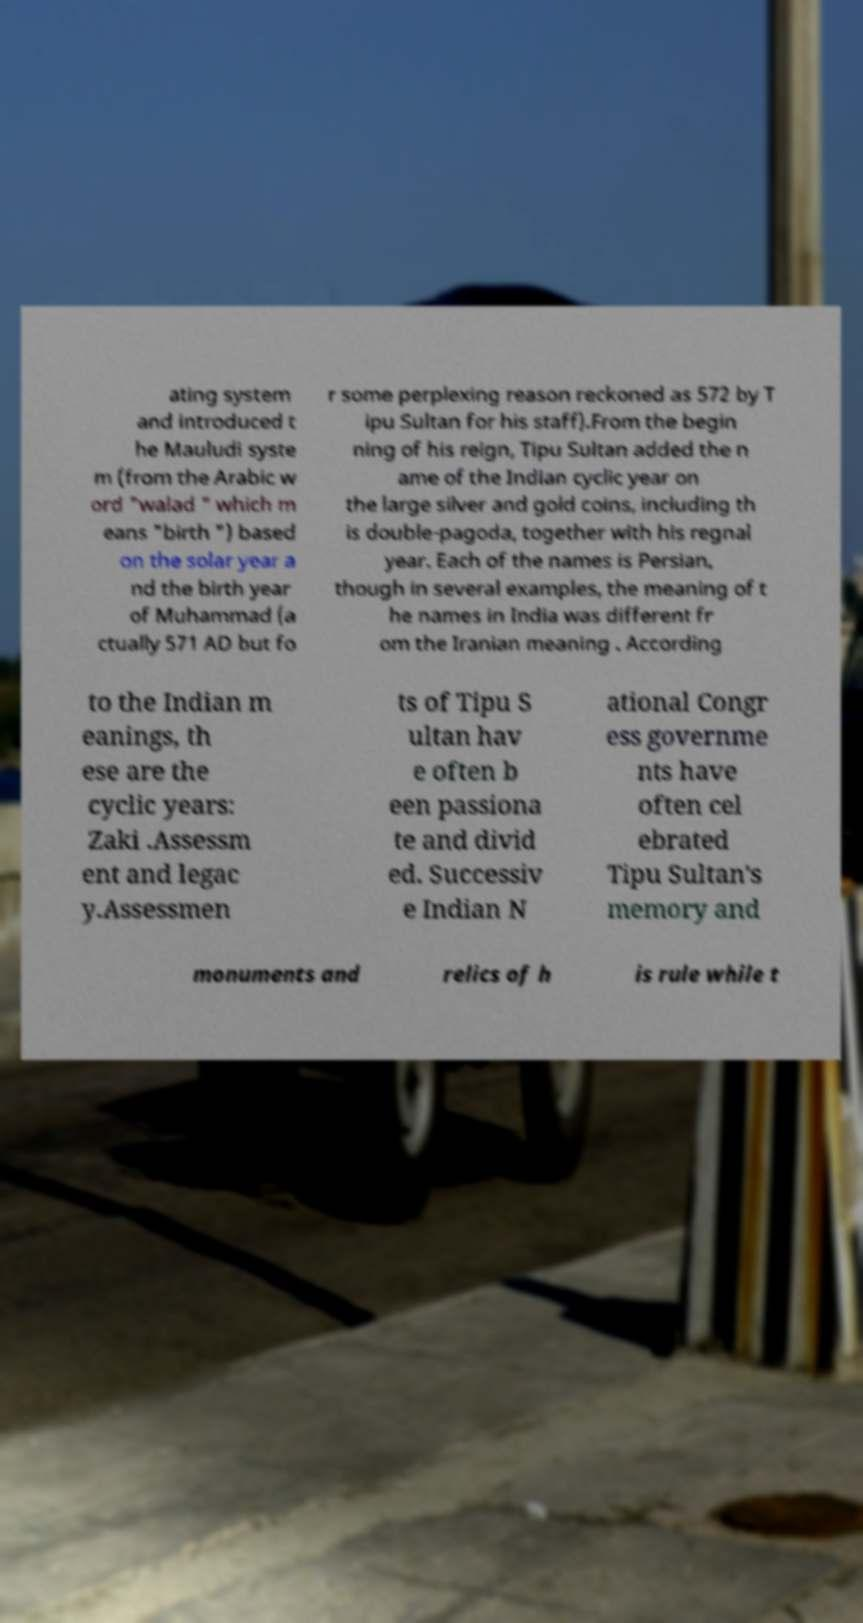Can you read and provide the text displayed in the image?This photo seems to have some interesting text. Can you extract and type it out for me? ating system and introduced t he Mauludi syste m (from the Arabic w ord "walad " which m eans "birth ") based on the solar year a nd the birth year of Muhammad (a ctually 571 AD but fo r some perplexing reason reckoned as 572 by T ipu Sultan for his staff).From the begin ning of his reign, Tipu Sultan added the n ame of the Indian cyclic year on the large silver and gold coins, including th is double-pagoda, together with his regnal year. Each of the names is Persian, though in several examples, the meaning of t he names in India was different fr om the Iranian meaning . According to the Indian m eanings, th ese are the cyclic years: Zaki .Assessm ent and legac y.Assessmen ts of Tipu S ultan hav e often b een passiona te and divid ed. Successiv e Indian N ational Congr ess governme nts have often cel ebrated Tipu Sultan's memory and monuments and relics of h is rule while t 